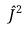<formula> <loc_0><loc_0><loc_500><loc_500>\hat { J } ^ { 2 }</formula> 